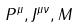Convert formula to latex. <formula><loc_0><loc_0><loc_500><loc_500>P ^ { \mu } , J ^ { \mu \nu } , M</formula> 